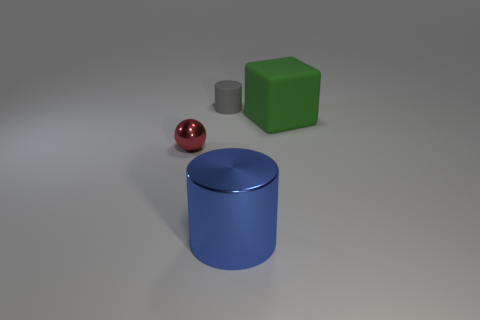Add 4 big blue metallic cylinders. How many objects exist? 8 Subtract all cubes. How many objects are left? 3 Subtract 0 purple cylinders. How many objects are left? 4 Subtract all cyan metallic balls. Subtract all cubes. How many objects are left? 3 Add 1 large metal things. How many large metal things are left? 2 Add 2 yellow metal things. How many yellow metal things exist? 2 